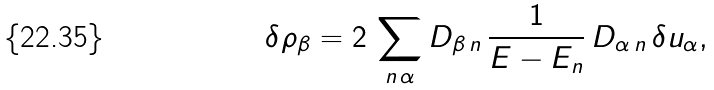Convert formula to latex. <formula><loc_0><loc_0><loc_500><loc_500>\delta \rho _ { \beta } = 2 \, \sum _ { n \, \alpha } D _ { \beta \, n } \, \frac { 1 } { E - E _ { n } } \, D _ { \alpha \, n } \, \delta u _ { \alpha } ,</formula> 